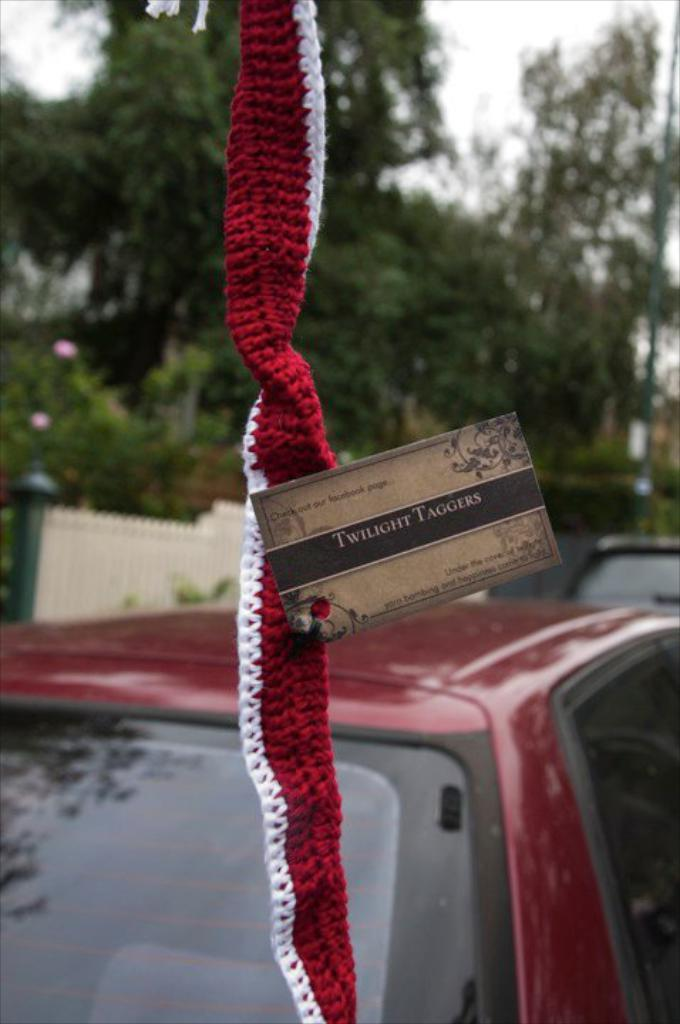What is the main object in the picture? There is a card in the picture. What is the card placed on? The card is on cloth. What can be seen in the background of the image? There are vehicles, a fence, trees, and the sky visible in the background of the image. Where can the honey be found in the image? There is no honey present in the image. What type of quicksand is visible in the image? There is no quicksand present in the image. 